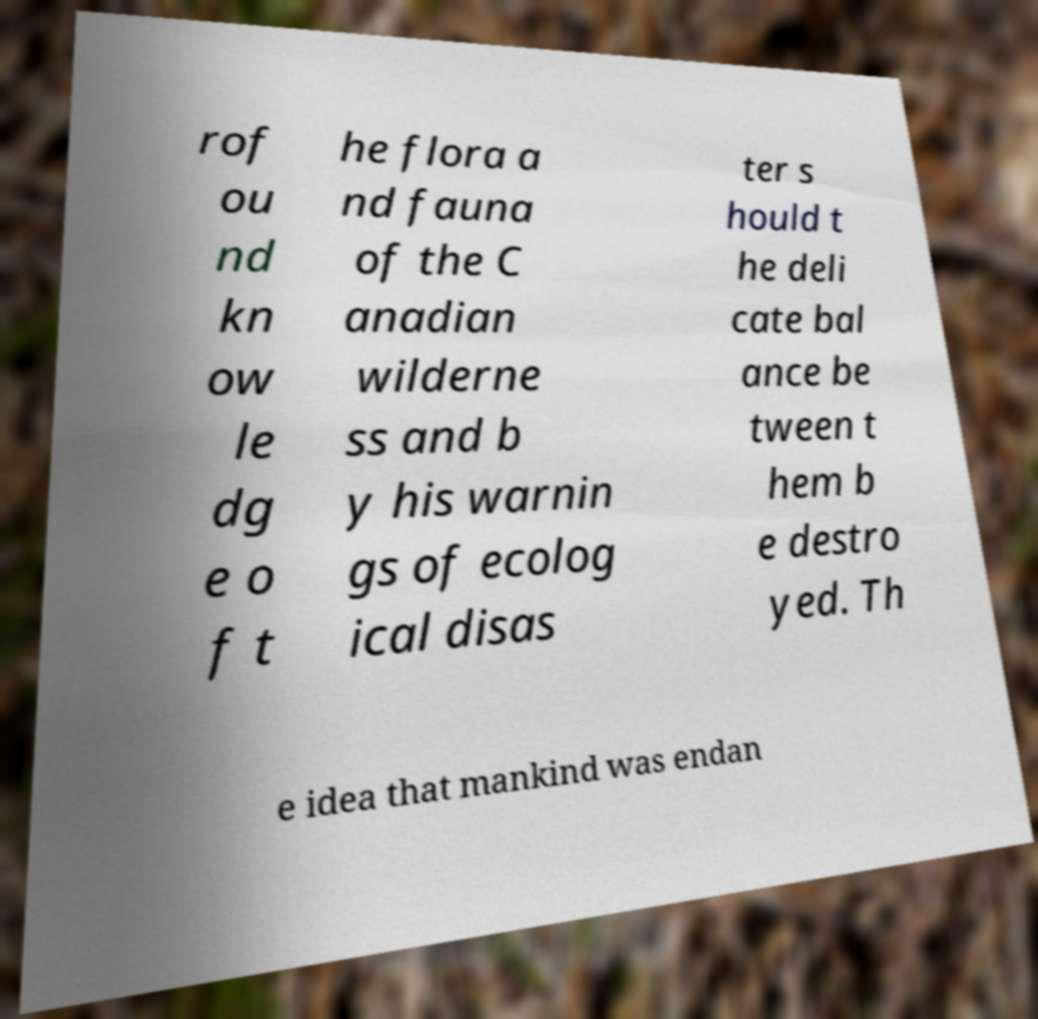Please identify and transcribe the text found in this image. rof ou nd kn ow le dg e o f t he flora a nd fauna of the C anadian wilderne ss and b y his warnin gs of ecolog ical disas ter s hould t he deli cate bal ance be tween t hem b e destro yed. Th e idea that mankind was endan 